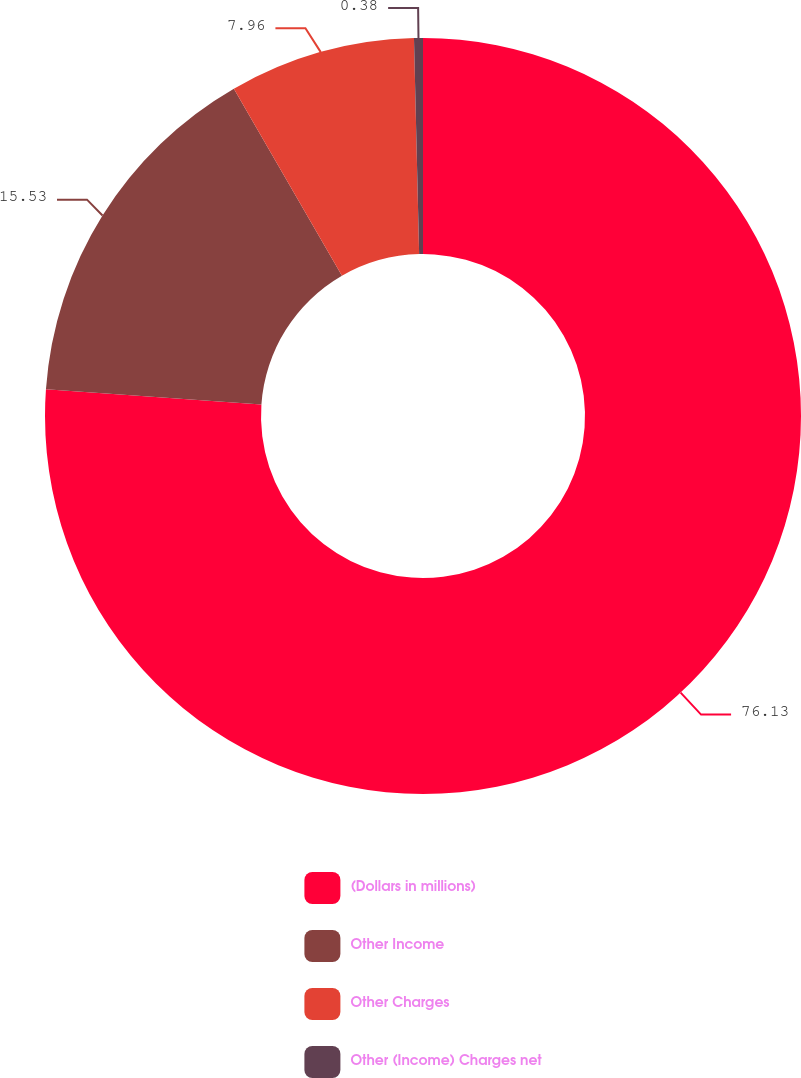<chart> <loc_0><loc_0><loc_500><loc_500><pie_chart><fcel>(Dollars in millions)<fcel>Other Income<fcel>Other Charges<fcel>Other (Income) Charges net<nl><fcel>76.13%<fcel>15.53%<fcel>7.96%<fcel>0.38%<nl></chart> 